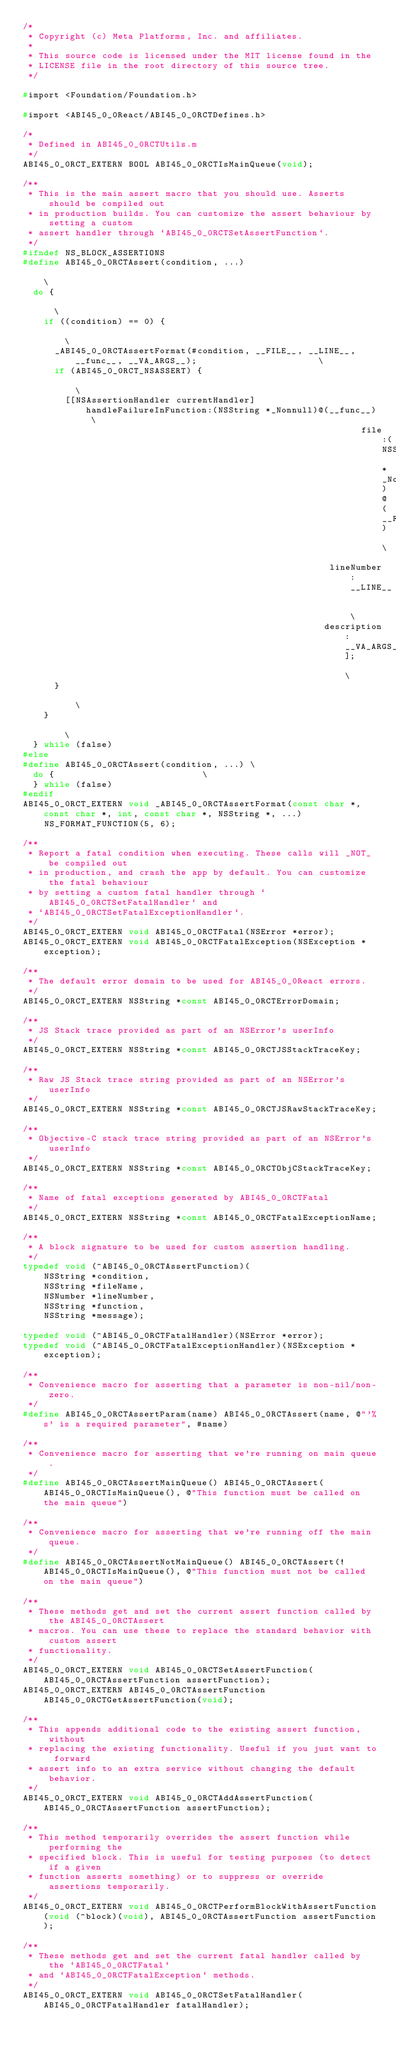<code> <loc_0><loc_0><loc_500><loc_500><_C_>/*
 * Copyright (c) Meta Platforms, Inc. and affiliates.
 *
 * This source code is licensed under the MIT license found in the
 * LICENSE file in the root directory of this source tree.
 */

#import <Foundation/Foundation.h>

#import <ABI45_0_0React/ABI45_0_0RCTDefines.h>

/*
 * Defined in ABI45_0_0RCTUtils.m
 */
ABI45_0_0RCT_EXTERN BOOL ABI45_0_0RCTIsMainQueue(void);

/**
 * This is the main assert macro that you should use. Asserts should be compiled out
 * in production builds. You can customize the assert behaviour by setting a custom
 * assert handler through `ABI45_0_0RCTSetAssertFunction`.
 */
#ifndef NS_BLOCK_ASSERTIONS
#define ABI45_0_0RCTAssert(condition, ...)                                                                    \
  do {                                                                                               \
    if ((condition) == 0) {                                                                          \
      _ABI45_0_0RCTAssertFormat(#condition, __FILE__, __LINE__, __func__, __VA_ARGS__);                       \
      if (ABI45_0_0RCT_NSASSERT) {                                                                            \
        [[NSAssertionHandler currentHandler] handleFailureInFunction:(NSString *_Nonnull)@(__func__) \
                                                                file:(NSString *_Nonnull)@(__FILE__) \
                                                          lineNumber:__LINE__                        \
                                                         description:__VA_ARGS__];                   \
      }                                                                                              \
    }                                                                                                \
  } while (false)
#else
#define ABI45_0_0RCTAssert(condition, ...) \
  do {                            \
  } while (false)
#endif
ABI45_0_0RCT_EXTERN void _ABI45_0_0RCTAssertFormat(const char *, const char *, int, const char *, NSString *, ...)
    NS_FORMAT_FUNCTION(5, 6);

/**
 * Report a fatal condition when executing. These calls will _NOT_ be compiled out
 * in production, and crash the app by default. You can customize the fatal behaviour
 * by setting a custom fatal handler through `ABI45_0_0RCTSetFatalHandler` and
 * `ABI45_0_0RCTSetFatalExceptionHandler`.
 */
ABI45_0_0RCT_EXTERN void ABI45_0_0RCTFatal(NSError *error);
ABI45_0_0RCT_EXTERN void ABI45_0_0RCTFatalException(NSException *exception);

/**
 * The default error domain to be used for ABI45_0_0React errors.
 */
ABI45_0_0RCT_EXTERN NSString *const ABI45_0_0RCTErrorDomain;

/**
 * JS Stack trace provided as part of an NSError's userInfo
 */
ABI45_0_0RCT_EXTERN NSString *const ABI45_0_0RCTJSStackTraceKey;

/**
 * Raw JS Stack trace string provided as part of an NSError's userInfo
 */
ABI45_0_0RCT_EXTERN NSString *const ABI45_0_0RCTJSRawStackTraceKey;

/**
 * Objective-C stack trace string provided as part of an NSError's userInfo
 */
ABI45_0_0RCT_EXTERN NSString *const ABI45_0_0RCTObjCStackTraceKey;

/**
 * Name of fatal exceptions generated by ABI45_0_0RCTFatal
 */
ABI45_0_0RCT_EXTERN NSString *const ABI45_0_0RCTFatalExceptionName;

/**
 * A block signature to be used for custom assertion handling.
 */
typedef void (^ABI45_0_0RCTAssertFunction)(
    NSString *condition,
    NSString *fileName,
    NSNumber *lineNumber,
    NSString *function,
    NSString *message);

typedef void (^ABI45_0_0RCTFatalHandler)(NSError *error);
typedef void (^ABI45_0_0RCTFatalExceptionHandler)(NSException *exception);

/**
 * Convenience macro for asserting that a parameter is non-nil/non-zero.
 */
#define ABI45_0_0RCTAssertParam(name) ABI45_0_0RCTAssert(name, @"'%s' is a required parameter", #name)

/**
 * Convenience macro for asserting that we're running on main queue.
 */
#define ABI45_0_0RCTAssertMainQueue() ABI45_0_0RCTAssert(ABI45_0_0RCTIsMainQueue(), @"This function must be called on the main queue")

/**
 * Convenience macro for asserting that we're running off the main queue.
 */
#define ABI45_0_0RCTAssertNotMainQueue() ABI45_0_0RCTAssert(!ABI45_0_0RCTIsMainQueue(), @"This function must not be called on the main queue")

/**
 * These methods get and set the current assert function called by the ABI45_0_0RCTAssert
 * macros. You can use these to replace the standard behavior with custom assert
 * functionality.
 */
ABI45_0_0RCT_EXTERN void ABI45_0_0RCTSetAssertFunction(ABI45_0_0RCTAssertFunction assertFunction);
ABI45_0_0RCT_EXTERN ABI45_0_0RCTAssertFunction ABI45_0_0RCTGetAssertFunction(void);

/**
 * This appends additional code to the existing assert function, without
 * replacing the existing functionality. Useful if you just want to forward
 * assert info to an extra service without changing the default behavior.
 */
ABI45_0_0RCT_EXTERN void ABI45_0_0RCTAddAssertFunction(ABI45_0_0RCTAssertFunction assertFunction);

/**
 * This method temporarily overrides the assert function while performing the
 * specified block. This is useful for testing purposes (to detect if a given
 * function asserts something) or to suppress or override assertions temporarily.
 */
ABI45_0_0RCT_EXTERN void ABI45_0_0RCTPerformBlockWithAssertFunction(void (^block)(void), ABI45_0_0RCTAssertFunction assertFunction);

/**
 * These methods get and set the current fatal handler called by the `ABI45_0_0RCTFatal`
 * and `ABI45_0_0RCTFatalException` methods.
 */
ABI45_0_0RCT_EXTERN void ABI45_0_0RCTSetFatalHandler(ABI45_0_0RCTFatalHandler fatalHandler);</code> 